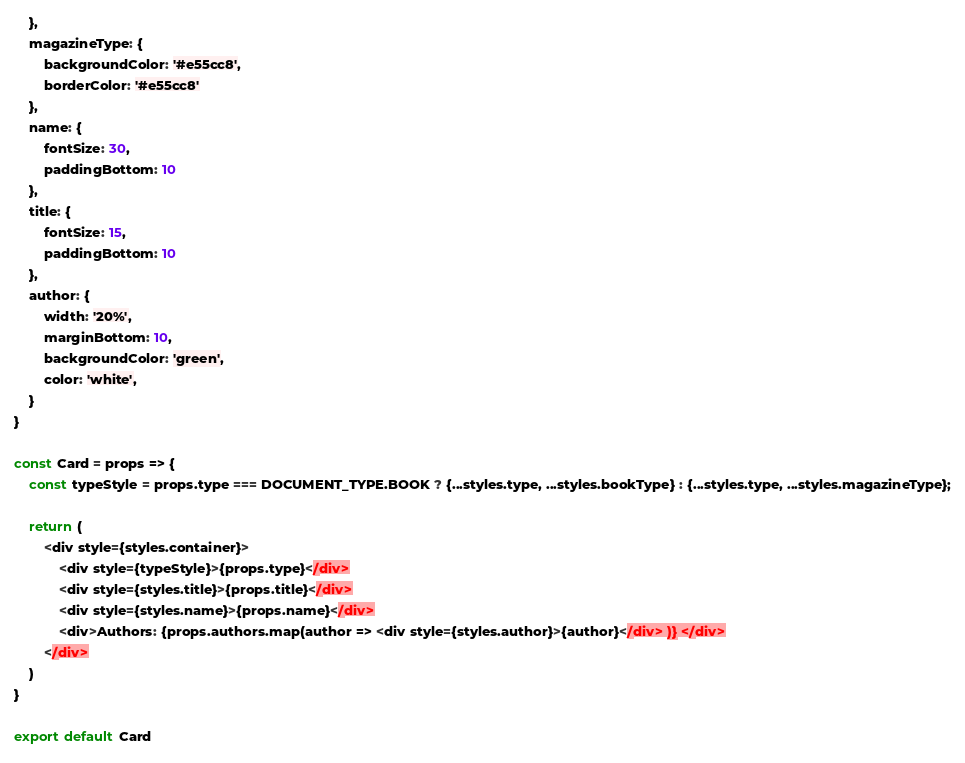<code> <loc_0><loc_0><loc_500><loc_500><_JavaScript_>    },
    magazineType: {
        backgroundColor: '#e55cc8',
        borderColor: '#e55cc8'
    },
    name: {
        fontSize: 30,
        paddingBottom: 10
    },
    title: {
        fontSize: 15,
        paddingBottom: 10
    },
    author: {
        width: '20%',
        marginBottom: 10,
        backgroundColor: 'green',
        color: 'white',
    }
}

const Card = props => {
    const typeStyle = props.type === DOCUMENT_TYPE.BOOK ? {...styles.type, ...styles.bookType} : {...styles.type, ...styles.magazineType};
    
    return (
        <div style={styles.container}>
            <div style={typeStyle}>{props.type}</div>
            <div style={styles.title}>{props.title}</div>
            <div style={styles.name}>{props.name}</div>
            <div>Authors: {props.authors.map(author => <div style={styles.author}>{author}</div> )} </div>
        </div>
    )
}

export default Card</code> 